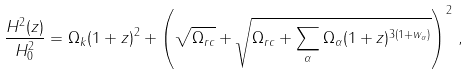<formula> <loc_0><loc_0><loc_500><loc_500>\frac { H ^ { 2 } ( z ) } { H _ { 0 } ^ { 2 } } = \Omega _ { k } ( 1 + z ) ^ { 2 } + \left ( \sqrt { \Omega _ { r c } } + \sqrt { \Omega _ { r c } + \sum _ { \alpha } \Omega _ { \alpha } ( 1 + z ) ^ { 3 ( 1 + w _ { \alpha } ) } } \right ) ^ { 2 } \, ,</formula> 